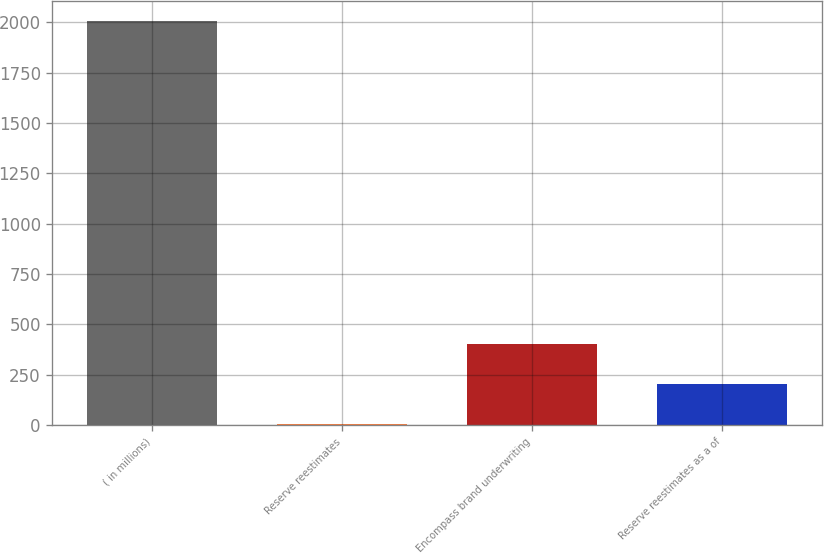<chart> <loc_0><loc_0><loc_500><loc_500><bar_chart><fcel>( in millions)<fcel>Reserve reestimates<fcel>Encompass brand underwriting<fcel>Reserve reestimates as a of<nl><fcel>2008<fcel>3<fcel>404<fcel>203.5<nl></chart> 